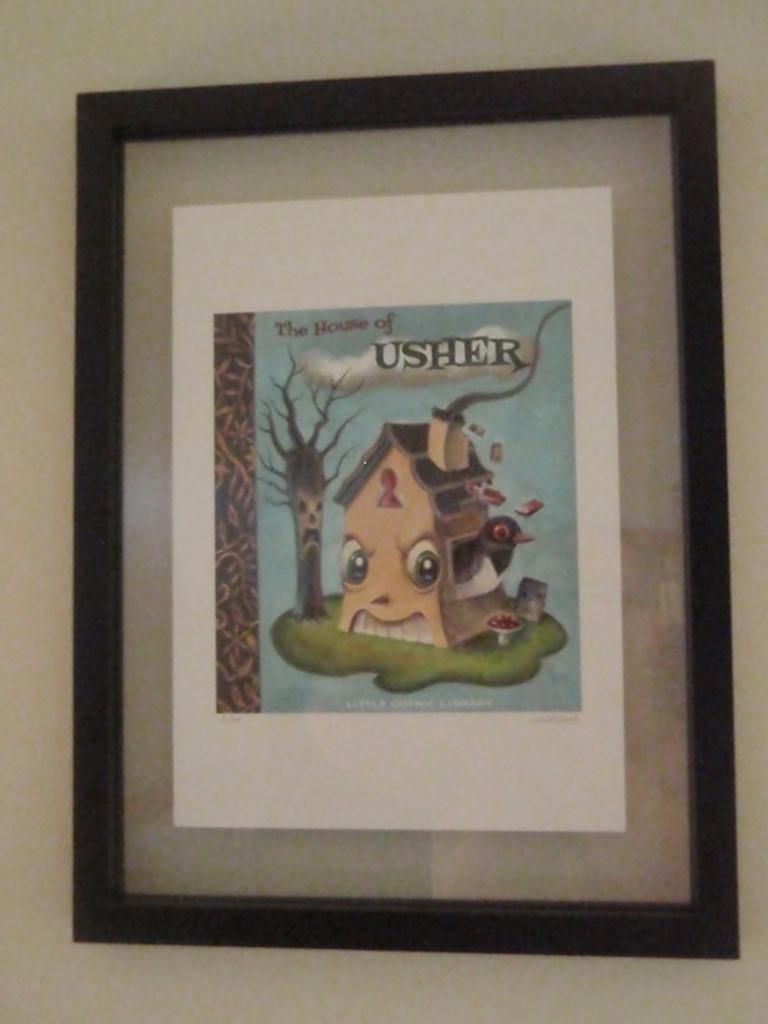Please provide a concise description of this image. In this picture we can see the drawing photo frame, placed on the white wall. 